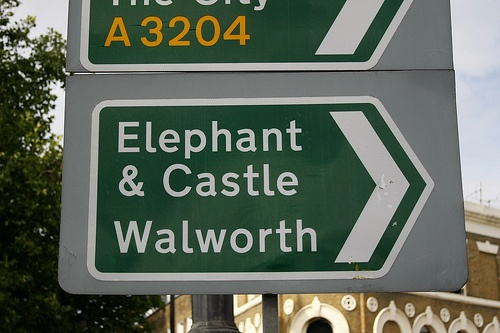Describe the objects in this image and their specific colors. I can see various objects in this image with different colors. 